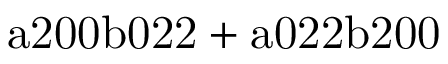Convert formula to latex. <formula><loc_0><loc_0><loc_500><loc_500>a 2 0 0 b 0 2 2 + a 0 2 2 b 2 0 0</formula> 